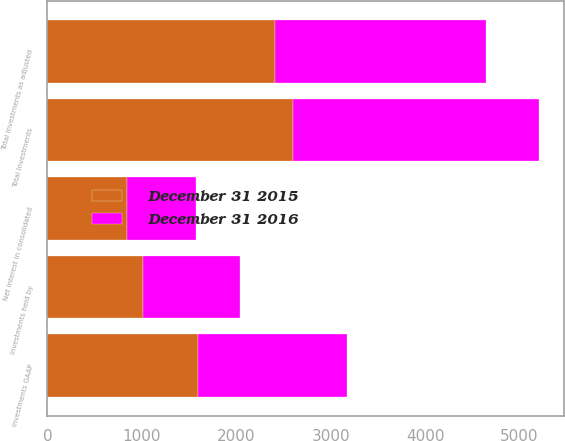Convert chart. <chart><loc_0><loc_0><loc_500><loc_500><stacked_bar_chart><ecel><fcel>Investments GAAP<fcel>Investments held by<fcel>Total Investments<fcel>Net interest in consolidated<fcel>Total Investments as adjusted<nl><fcel>December 31 2015<fcel>1595<fcel>1008<fcel>2603<fcel>840<fcel>2414<nl><fcel>December 31 2016<fcel>1578<fcel>1030<fcel>2608<fcel>733<fcel>2227<nl></chart> 